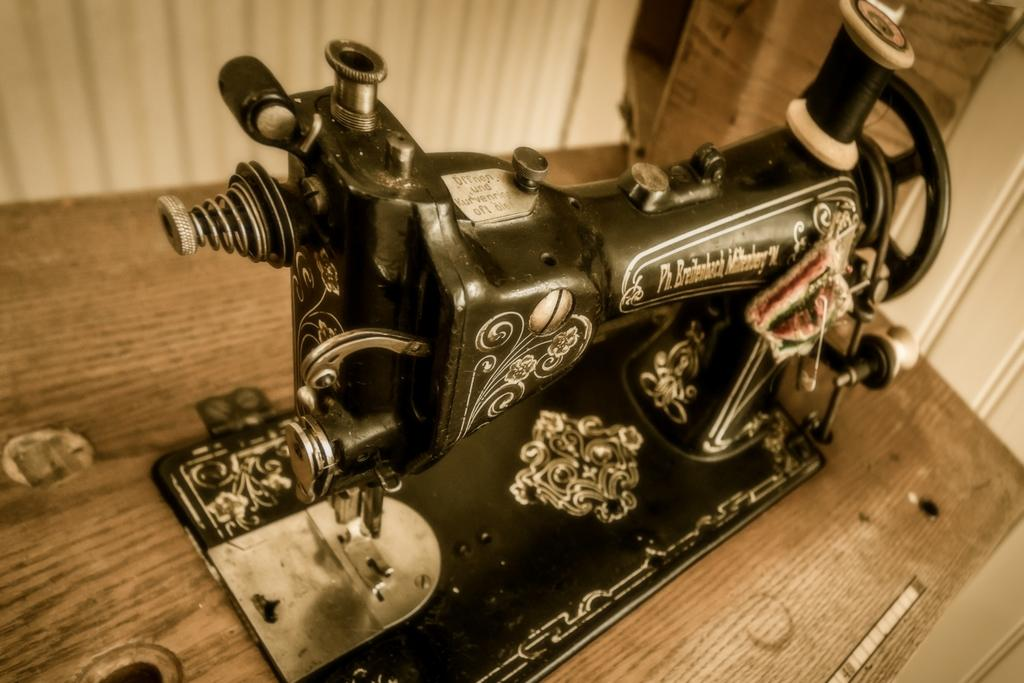What is the main object in the picture? There is a stitching machine in the picture. What is the color of the stitching machine? The stitching machine is black in color. Are there any patterns or designs on the stitching machine? Yes, the stitching machine has designs on it. What is supporting the stitching machine in the picture? There is a wooden plank under the stitching machine. What can be seen behind the stitching machine? There is a wall behind the stitching machine. Can you see a donkey wearing a mask in the picture? No, there is no donkey or mask present in the image. 